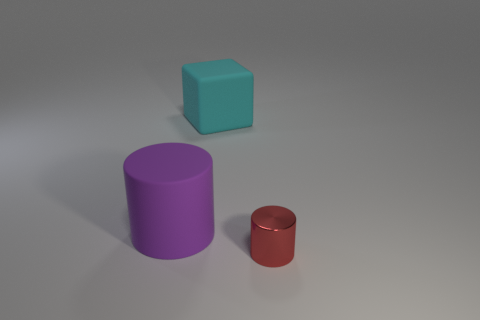Add 3 brown spheres. How many objects exist? 6 Subtract 1 blocks. How many blocks are left? 0 Subtract all blocks. How many objects are left? 2 Subtract all blue cubes. How many cyan cylinders are left? 0 Subtract all big cyan things. Subtract all purple matte things. How many objects are left? 1 Add 2 large rubber cylinders. How many large rubber cylinders are left? 3 Add 1 large blue balls. How many large blue balls exist? 1 Subtract all red cylinders. How many cylinders are left? 1 Subtract 0 green blocks. How many objects are left? 3 Subtract all purple cylinders. Subtract all purple cubes. How many cylinders are left? 1 